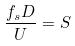<formula> <loc_0><loc_0><loc_500><loc_500>\frac { f _ { s } D } { U } = S</formula> 